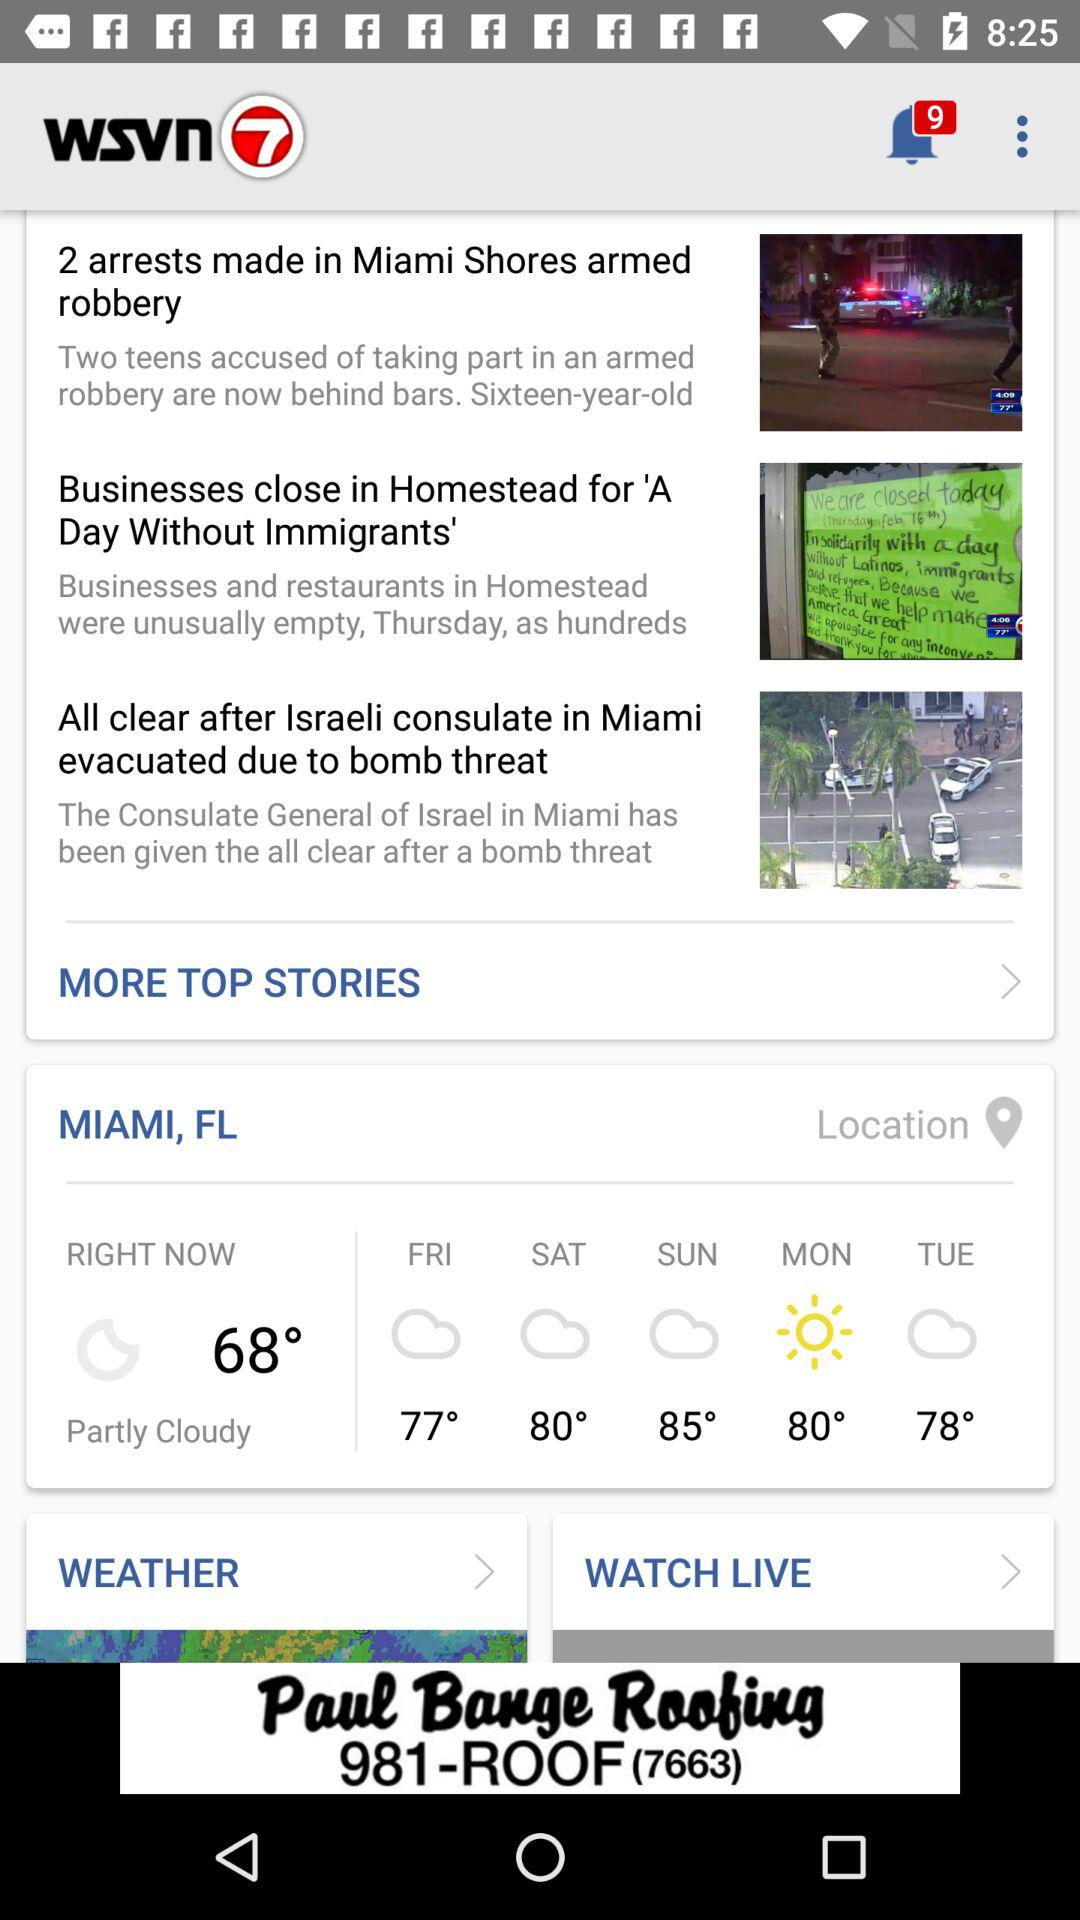What will the temperature be on Friday? The temperature on Friday will be 77 degrees. 